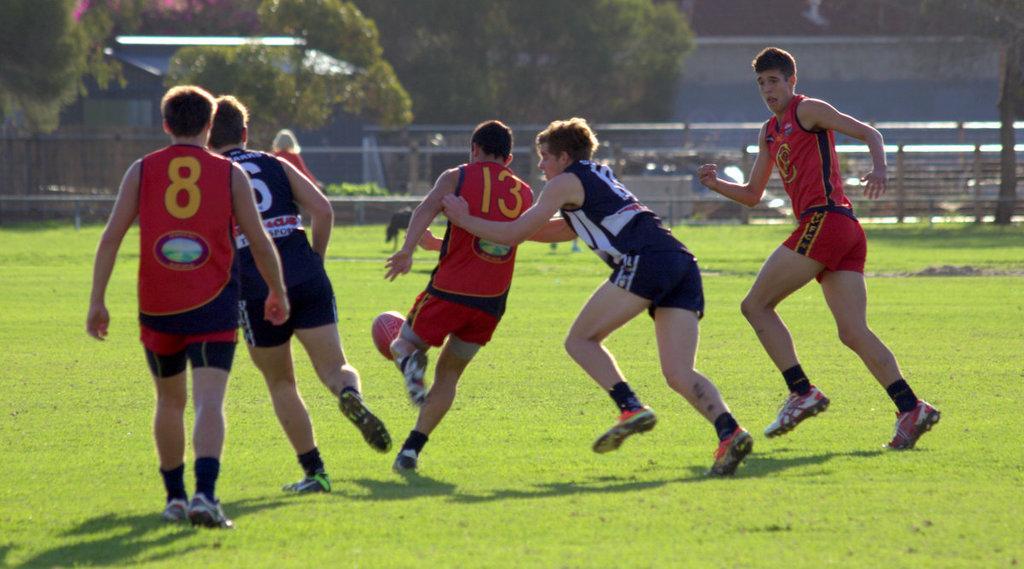In one or two sentences, can you explain what this image depicts? This picture is of outside which is a playground. On the right there is a man wearing red color t-shirt and running. In the center there are two persons running and trying to kick the ball. On the left there is a man wearing blue color t-shirt and running, beside him there is a man wearing red color t-shirt and seems to be walking. In the background we can see the trees, some plants and the ground full of green grass. 